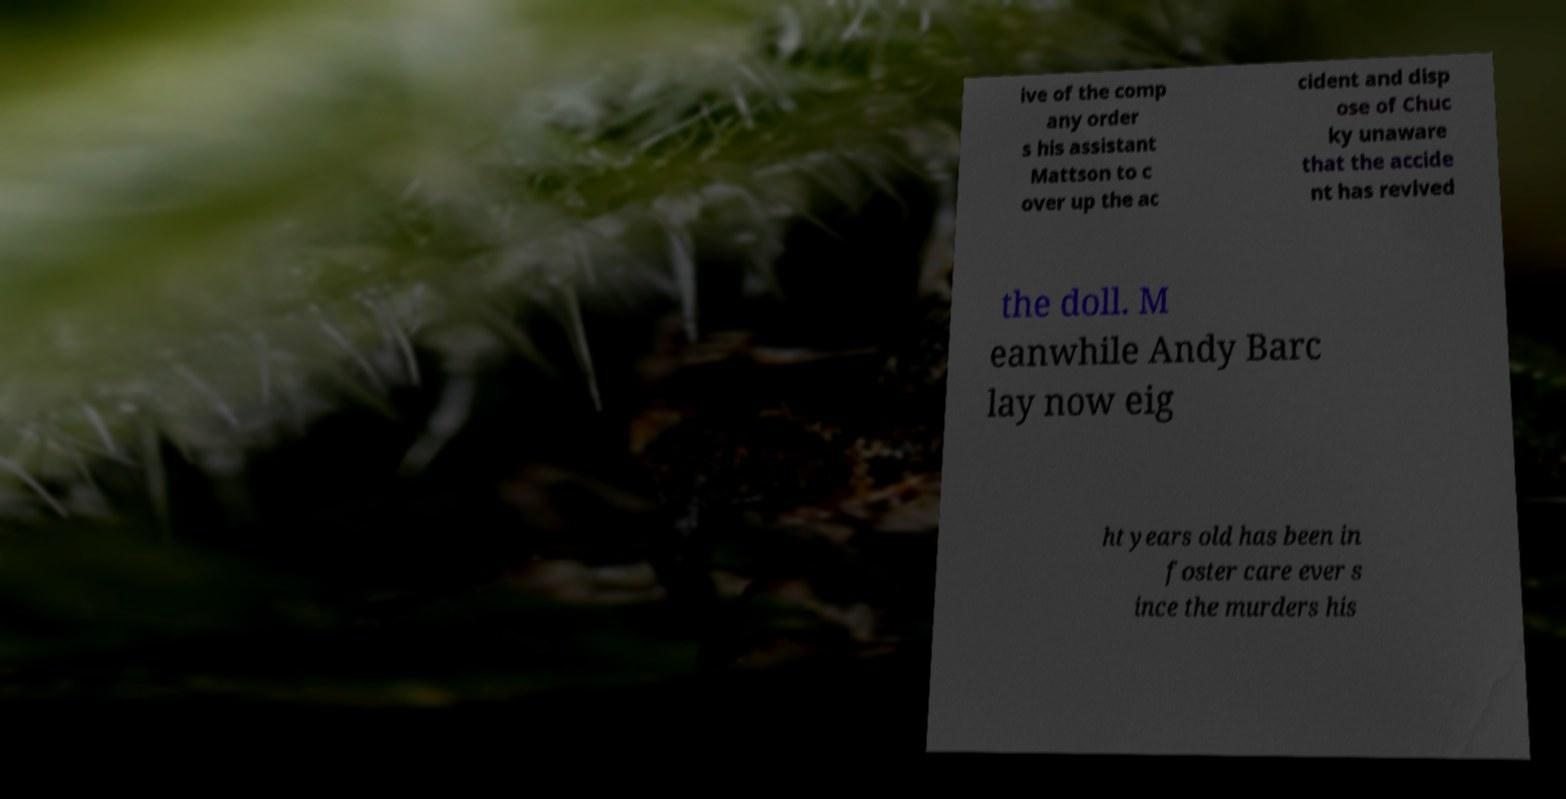Can you accurately transcribe the text from the provided image for me? ive of the comp any order s his assistant Mattson to c over up the ac cident and disp ose of Chuc ky unaware that the accide nt has revived the doll. M eanwhile Andy Barc lay now eig ht years old has been in foster care ever s ince the murders his 